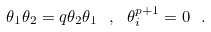Convert formula to latex. <formula><loc_0><loc_0><loc_500><loc_500>\theta _ { 1 } \theta _ { 2 } = q \theta _ { 2 } \theta _ { 1 } \ , \ \theta _ { i } ^ { p + 1 } = 0 \ .</formula> 